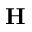<formula> <loc_0><loc_0><loc_500><loc_500>H</formula> 